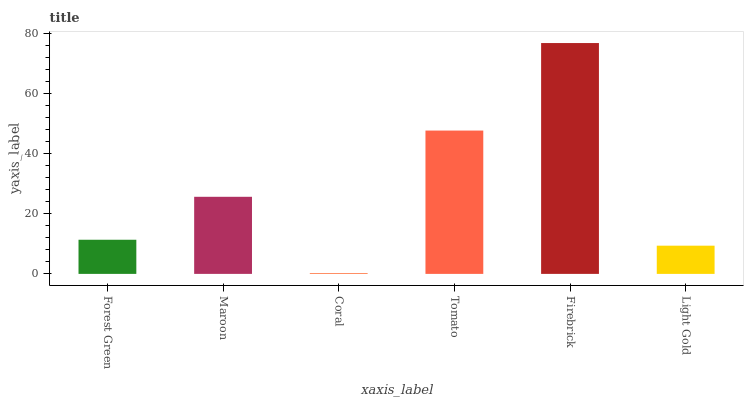Is Coral the minimum?
Answer yes or no. Yes. Is Firebrick the maximum?
Answer yes or no. Yes. Is Maroon the minimum?
Answer yes or no. No. Is Maroon the maximum?
Answer yes or no. No. Is Maroon greater than Forest Green?
Answer yes or no. Yes. Is Forest Green less than Maroon?
Answer yes or no. Yes. Is Forest Green greater than Maroon?
Answer yes or no. No. Is Maroon less than Forest Green?
Answer yes or no. No. Is Maroon the high median?
Answer yes or no. Yes. Is Forest Green the low median?
Answer yes or no. Yes. Is Firebrick the high median?
Answer yes or no. No. Is Firebrick the low median?
Answer yes or no. No. 